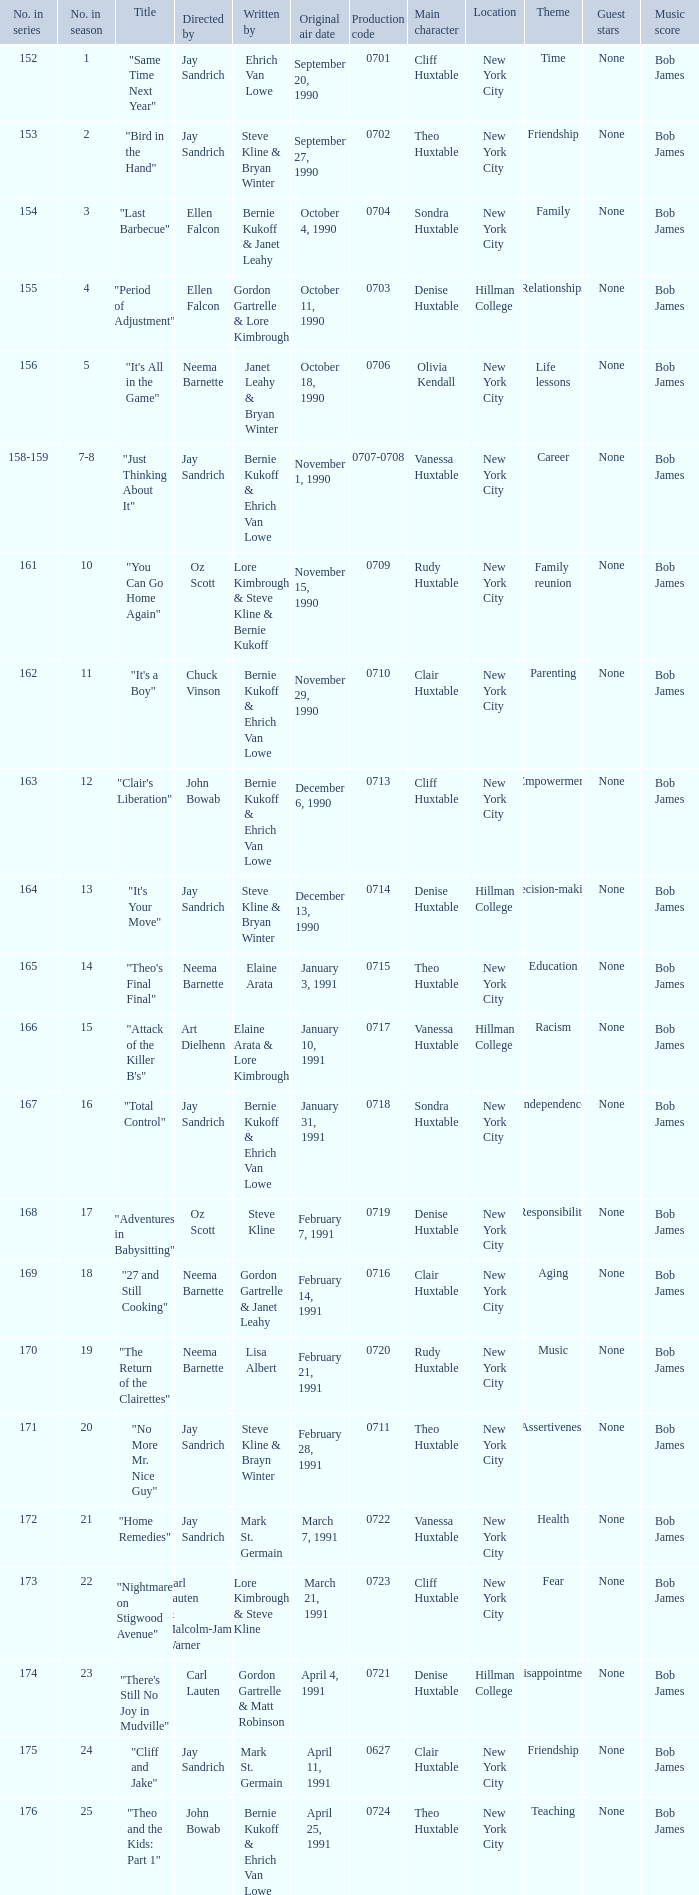The episode directed by art dielhenn was what number in the series?  166.0. 